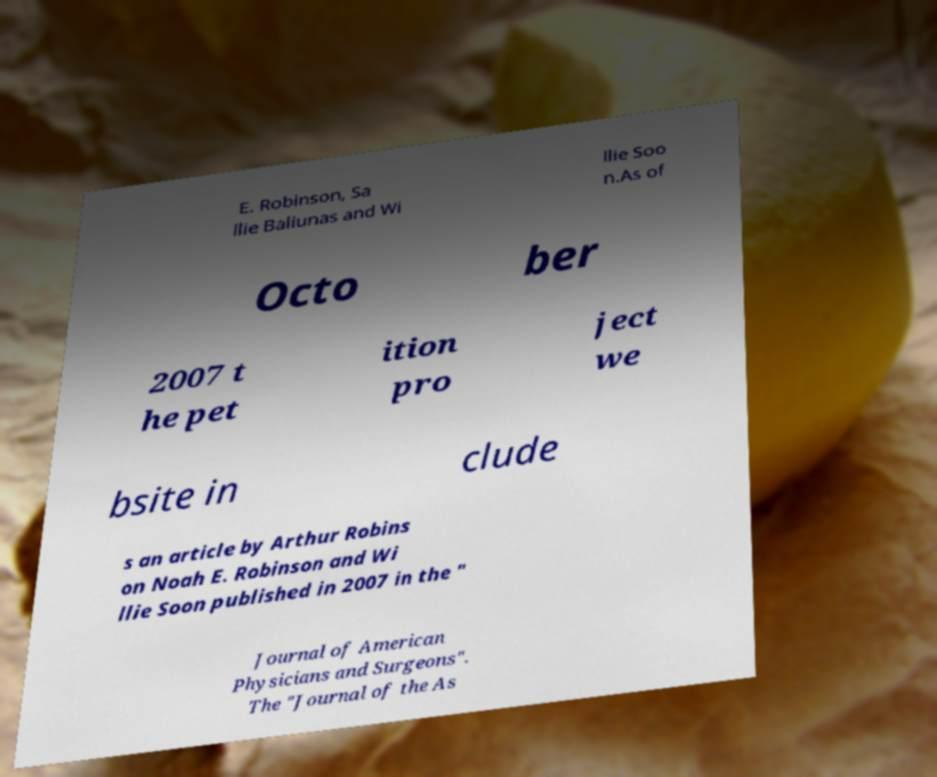There's text embedded in this image that I need extracted. Can you transcribe it verbatim? E. Robinson, Sa llie Baliunas and Wi llie Soo n.As of Octo ber 2007 t he pet ition pro ject we bsite in clude s an article by Arthur Robins on Noah E. Robinson and Wi llie Soon published in 2007 in the " Journal of American Physicians and Surgeons". The "Journal of the As 